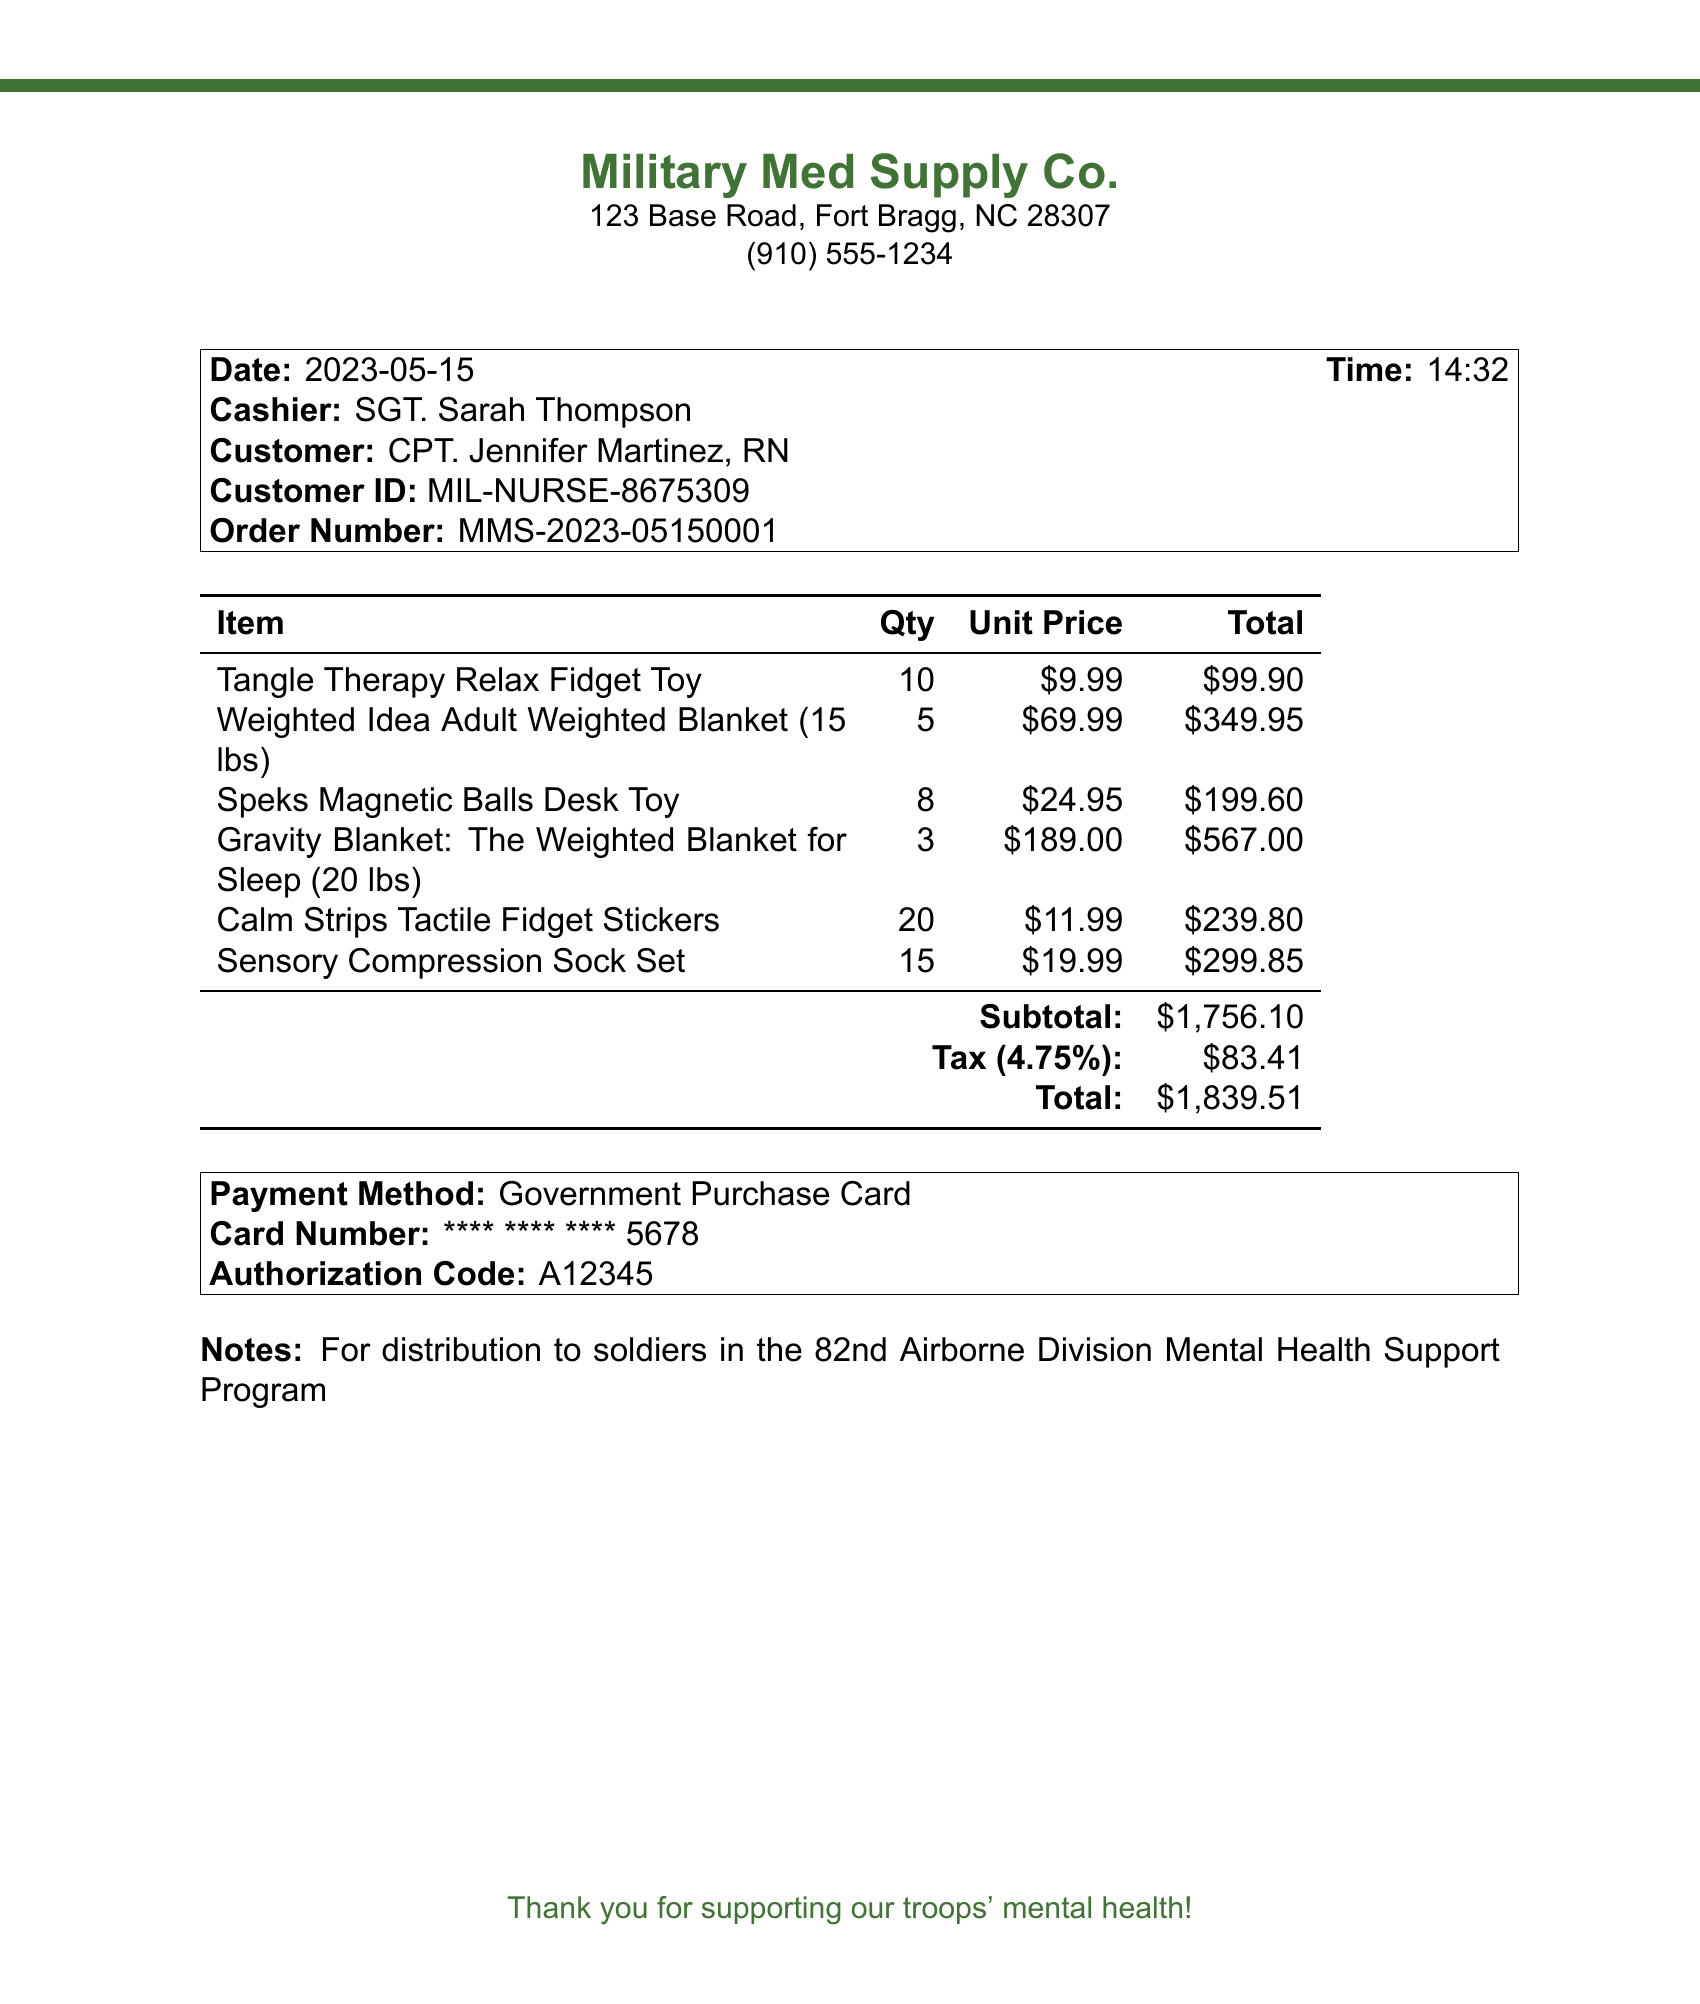What is the store name? The store name is listed at the top of the document as "Military Med Supply Co."
Answer: Military Med Supply Co Who is the cashier? The cashier's name is indicated in the document under customer details.
Answer: SGT. Sarah Thompson What is the date of the transaction? The date is shown in the receipt underneath the customer information.
Answer: 2023-05-15 How many Tangle Therapy Relax Fidget Toys were purchased? The quantity can be found in the itemized list of purchases.
Answer: 10 What is the total amount paid including tax? The total amount is provided at the end of the itemization, including the subtotal and tax.
Answer: $1,839.51 What is the tax rate applied? The tax rate is mentioned right before the tax amount calculation.
Answer: 4.75% What was the payment method? The payment method is specified in the payment section of the receipt.
Answer: Government Purchase Card For whom were these items purchased? The intended recipients of the items are detailed in the notes section of the receipt.
Answer: soldiers in the 82nd Airborne Division Mental Health Support Program How many items of Sensory Compression Sock Sets were bought? The quantity is clearly stated in the itemized list of the receipt.
Answer: 15 